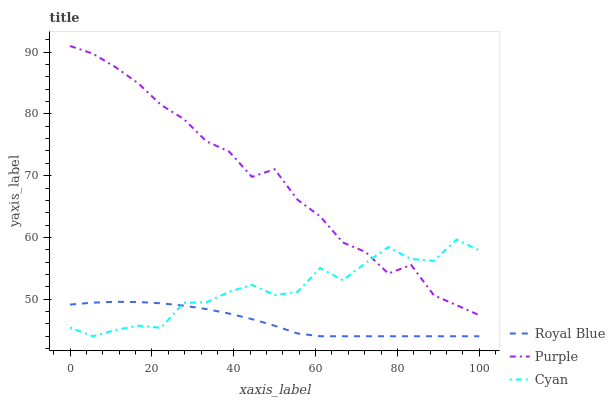Does Cyan have the minimum area under the curve?
Answer yes or no. No. Does Cyan have the maximum area under the curve?
Answer yes or no. No. Is Cyan the smoothest?
Answer yes or no. No. Is Royal Blue the roughest?
Answer yes or no. No. Does Cyan have the highest value?
Answer yes or no. No. Is Royal Blue less than Purple?
Answer yes or no. Yes. Is Purple greater than Royal Blue?
Answer yes or no. Yes. Does Royal Blue intersect Purple?
Answer yes or no. No. 